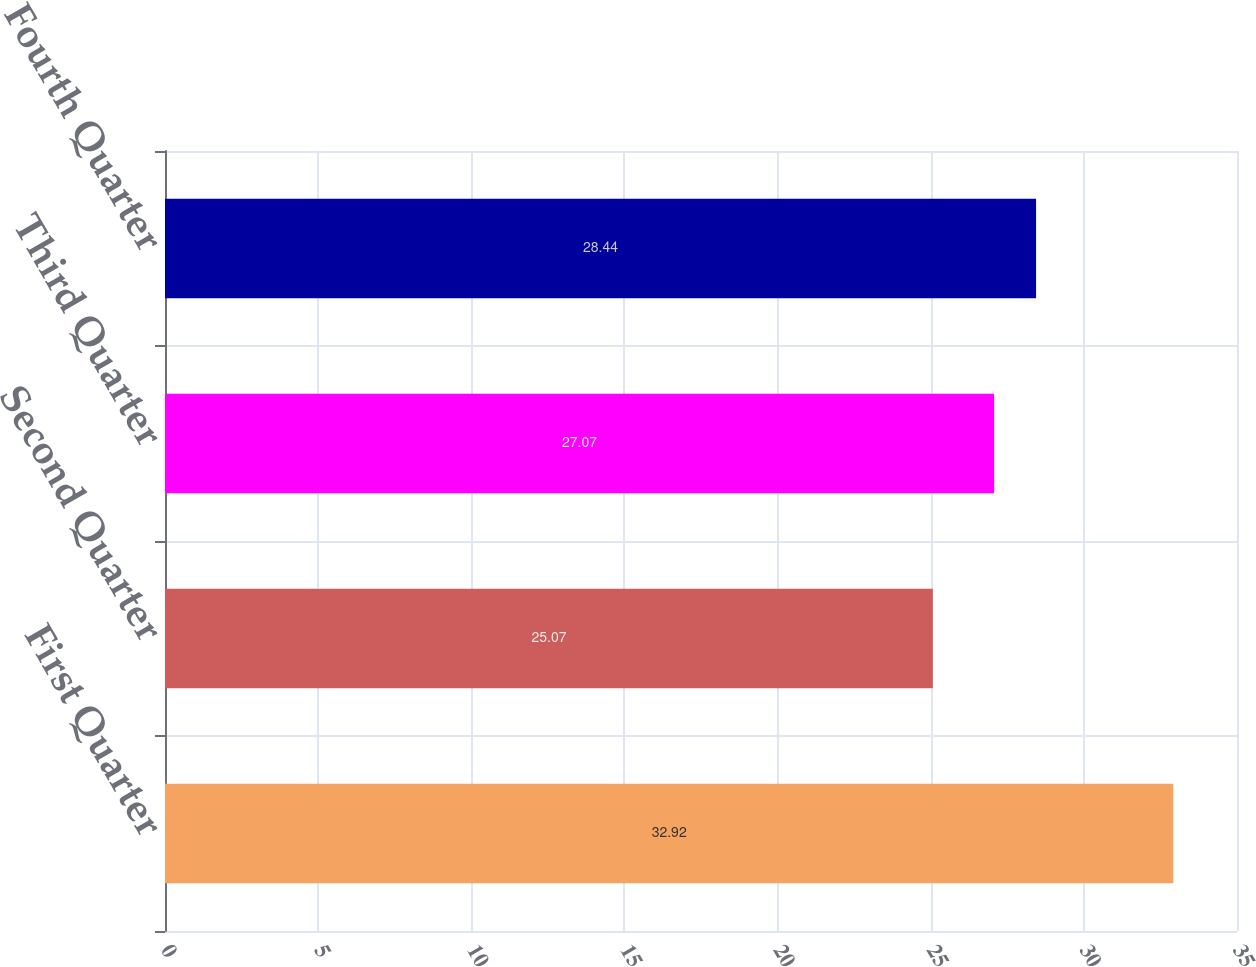Convert chart. <chart><loc_0><loc_0><loc_500><loc_500><bar_chart><fcel>First Quarter<fcel>Second Quarter<fcel>Third Quarter<fcel>Fourth Quarter<nl><fcel>32.92<fcel>25.07<fcel>27.07<fcel>28.44<nl></chart> 